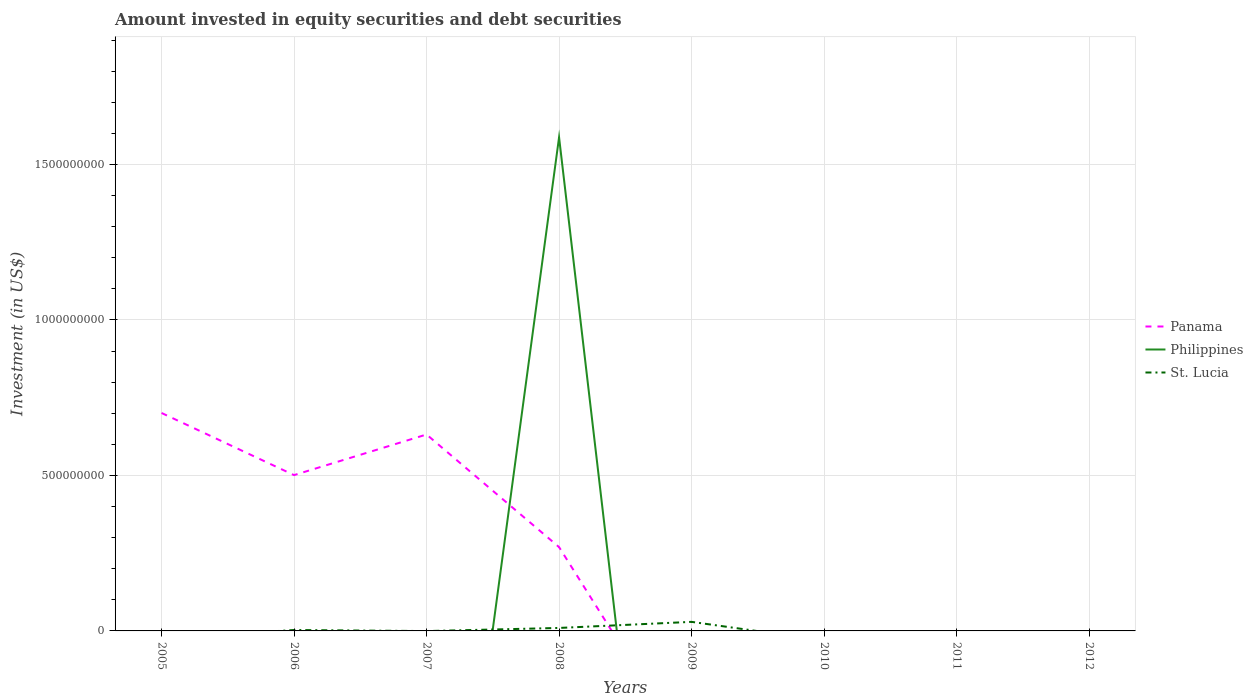Across all years, what is the maximum amount invested in equity securities and debt securities in Panama?
Give a very brief answer. 0. What is the difference between the highest and the second highest amount invested in equity securities and debt securities in Panama?
Offer a terse response. 7.01e+08. What is the difference between the highest and the lowest amount invested in equity securities and debt securities in Philippines?
Your answer should be very brief. 1. Is the amount invested in equity securities and debt securities in Panama strictly greater than the amount invested in equity securities and debt securities in St. Lucia over the years?
Offer a terse response. No. How many lines are there?
Provide a succinct answer. 3. How many years are there in the graph?
Offer a very short reply. 8. Does the graph contain any zero values?
Your answer should be compact. Yes. Where does the legend appear in the graph?
Give a very brief answer. Center right. How many legend labels are there?
Provide a succinct answer. 3. What is the title of the graph?
Give a very brief answer. Amount invested in equity securities and debt securities. What is the label or title of the X-axis?
Your answer should be very brief. Years. What is the label or title of the Y-axis?
Make the answer very short. Investment (in US$). What is the Investment (in US$) of Panama in 2005?
Offer a terse response. 7.01e+08. What is the Investment (in US$) in Philippines in 2005?
Your answer should be very brief. 0. What is the Investment (in US$) in St. Lucia in 2005?
Make the answer very short. 0. What is the Investment (in US$) in Panama in 2006?
Make the answer very short. 5.01e+08. What is the Investment (in US$) in St. Lucia in 2006?
Ensure brevity in your answer.  2.96e+06. What is the Investment (in US$) of Panama in 2007?
Make the answer very short. 6.32e+08. What is the Investment (in US$) in Philippines in 2007?
Offer a terse response. 0. What is the Investment (in US$) of St. Lucia in 2007?
Offer a terse response. 0. What is the Investment (in US$) of Panama in 2008?
Your answer should be very brief. 2.70e+08. What is the Investment (in US$) of Philippines in 2008?
Provide a succinct answer. 1.59e+09. What is the Investment (in US$) of St. Lucia in 2008?
Your answer should be compact. 9.56e+06. What is the Investment (in US$) in Panama in 2009?
Offer a very short reply. 0. What is the Investment (in US$) of St. Lucia in 2009?
Your answer should be compact. 2.91e+07. What is the Investment (in US$) of Panama in 2010?
Your answer should be compact. 0. What is the Investment (in US$) of Philippines in 2010?
Your answer should be very brief. 0. Across all years, what is the maximum Investment (in US$) of Panama?
Your response must be concise. 7.01e+08. Across all years, what is the maximum Investment (in US$) in Philippines?
Ensure brevity in your answer.  1.59e+09. Across all years, what is the maximum Investment (in US$) of St. Lucia?
Provide a short and direct response. 2.91e+07. What is the total Investment (in US$) in Panama in the graph?
Offer a very short reply. 2.10e+09. What is the total Investment (in US$) of Philippines in the graph?
Ensure brevity in your answer.  1.59e+09. What is the total Investment (in US$) of St. Lucia in the graph?
Give a very brief answer. 4.17e+07. What is the difference between the Investment (in US$) in Panama in 2005 and that in 2006?
Offer a terse response. 2.00e+08. What is the difference between the Investment (in US$) of Panama in 2005 and that in 2007?
Make the answer very short. 6.92e+07. What is the difference between the Investment (in US$) of Panama in 2005 and that in 2008?
Ensure brevity in your answer.  4.31e+08. What is the difference between the Investment (in US$) in Panama in 2006 and that in 2007?
Give a very brief answer. -1.31e+08. What is the difference between the Investment (in US$) in Panama in 2006 and that in 2008?
Provide a short and direct response. 2.32e+08. What is the difference between the Investment (in US$) in St. Lucia in 2006 and that in 2008?
Offer a terse response. -6.60e+06. What is the difference between the Investment (in US$) of St. Lucia in 2006 and that in 2009?
Provide a succinct answer. -2.62e+07. What is the difference between the Investment (in US$) in Panama in 2007 and that in 2008?
Provide a succinct answer. 3.62e+08. What is the difference between the Investment (in US$) in St. Lucia in 2008 and that in 2009?
Your answer should be compact. -1.96e+07. What is the difference between the Investment (in US$) of Panama in 2005 and the Investment (in US$) of St. Lucia in 2006?
Your response must be concise. 6.98e+08. What is the difference between the Investment (in US$) in Panama in 2005 and the Investment (in US$) in Philippines in 2008?
Provide a short and direct response. -8.86e+08. What is the difference between the Investment (in US$) in Panama in 2005 and the Investment (in US$) in St. Lucia in 2008?
Offer a terse response. 6.91e+08. What is the difference between the Investment (in US$) in Panama in 2005 and the Investment (in US$) in St. Lucia in 2009?
Provide a succinct answer. 6.72e+08. What is the difference between the Investment (in US$) of Panama in 2006 and the Investment (in US$) of Philippines in 2008?
Your answer should be very brief. -1.09e+09. What is the difference between the Investment (in US$) in Panama in 2006 and the Investment (in US$) in St. Lucia in 2008?
Your answer should be compact. 4.91e+08. What is the difference between the Investment (in US$) in Panama in 2006 and the Investment (in US$) in St. Lucia in 2009?
Your answer should be compact. 4.72e+08. What is the difference between the Investment (in US$) of Panama in 2007 and the Investment (in US$) of Philippines in 2008?
Make the answer very short. -9.56e+08. What is the difference between the Investment (in US$) of Panama in 2007 and the Investment (in US$) of St. Lucia in 2008?
Provide a succinct answer. 6.22e+08. What is the difference between the Investment (in US$) in Panama in 2007 and the Investment (in US$) in St. Lucia in 2009?
Give a very brief answer. 6.02e+08. What is the difference between the Investment (in US$) of Panama in 2008 and the Investment (in US$) of St. Lucia in 2009?
Keep it short and to the point. 2.40e+08. What is the difference between the Investment (in US$) of Philippines in 2008 and the Investment (in US$) of St. Lucia in 2009?
Offer a very short reply. 1.56e+09. What is the average Investment (in US$) in Panama per year?
Provide a short and direct response. 2.63e+08. What is the average Investment (in US$) in Philippines per year?
Provide a succinct answer. 1.98e+08. What is the average Investment (in US$) of St. Lucia per year?
Give a very brief answer. 5.21e+06. In the year 2006, what is the difference between the Investment (in US$) of Panama and Investment (in US$) of St. Lucia?
Your answer should be very brief. 4.98e+08. In the year 2008, what is the difference between the Investment (in US$) in Panama and Investment (in US$) in Philippines?
Offer a very short reply. -1.32e+09. In the year 2008, what is the difference between the Investment (in US$) of Panama and Investment (in US$) of St. Lucia?
Your answer should be compact. 2.60e+08. In the year 2008, what is the difference between the Investment (in US$) of Philippines and Investment (in US$) of St. Lucia?
Give a very brief answer. 1.58e+09. What is the ratio of the Investment (in US$) in Panama in 2005 to that in 2006?
Provide a short and direct response. 1.4. What is the ratio of the Investment (in US$) in Panama in 2005 to that in 2007?
Your response must be concise. 1.11. What is the ratio of the Investment (in US$) in Panama in 2005 to that in 2008?
Ensure brevity in your answer.  2.6. What is the ratio of the Investment (in US$) of Panama in 2006 to that in 2007?
Make the answer very short. 0.79. What is the ratio of the Investment (in US$) in Panama in 2006 to that in 2008?
Your response must be concise. 1.86. What is the ratio of the Investment (in US$) in St. Lucia in 2006 to that in 2008?
Provide a short and direct response. 0.31. What is the ratio of the Investment (in US$) in St. Lucia in 2006 to that in 2009?
Offer a very short reply. 0.1. What is the ratio of the Investment (in US$) of Panama in 2007 to that in 2008?
Make the answer very short. 2.34. What is the ratio of the Investment (in US$) in St. Lucia in 2008 to that in 2009?
Give a very brief answer. 0.33. What is the difference between the highest and the second highest Investment (in US$) of Panama?
Provide a succinct answer. 6.92e+07. What is the difference between the highest and the second highest Investment (in US$) in St. Lucia?
Offer a terse response. 1.96e+07. What is the difference between the highest and the lowest Investment (in US$) of Panama?
Offer a very short reply. 7.01e+08. What is the difference between the highest and the lowest Investment (in US$) in Philippines?
Offer a terse response. 1.59e+09. What is the difference between the highest and the lowest Investment (in US$) of St. Lucia?
Make the answer very short. 2.91e+07. 